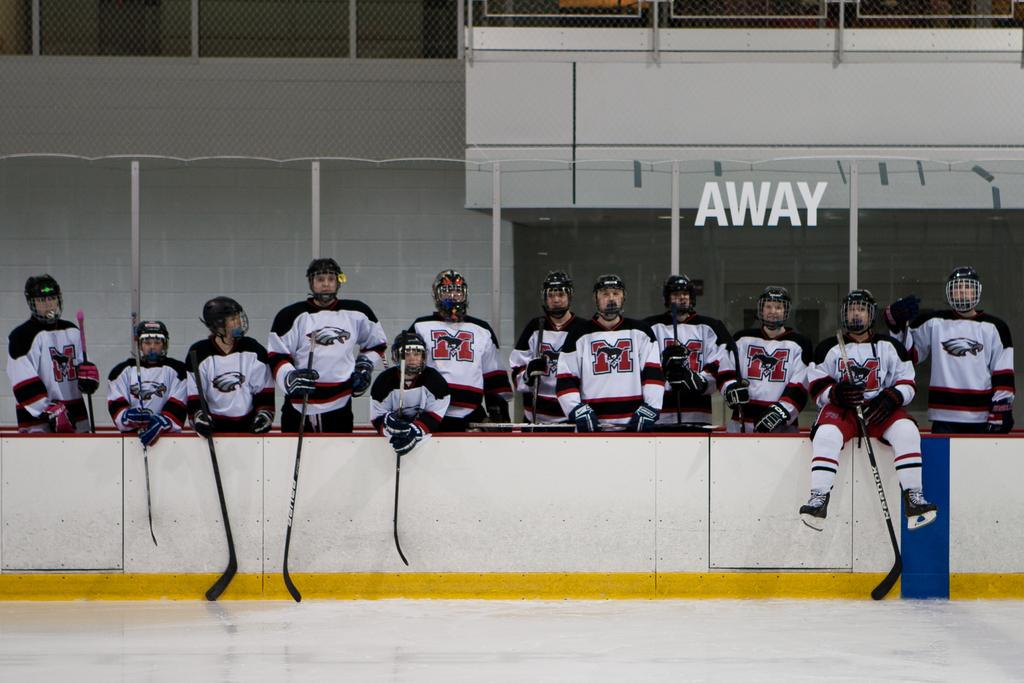<image>
Share a concise interpretation of the image provided. A team of hockey players in front of a glass wall with AWAY on it. 